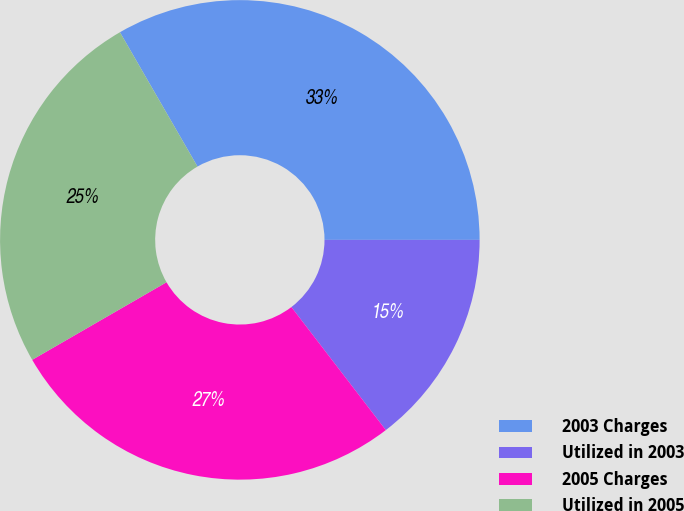<chart> <loc_0><loc_0><loc_500><loc_500><pie_chart><fcel>2003 Charges<fcel>Utilized in 2003<fcel>2005 Charges<fcel>Utilized in 2005<nl><fcel>33.33%<fcel>14.58%<fcel>27.08%<fcel>25.0%<nl></chart> 